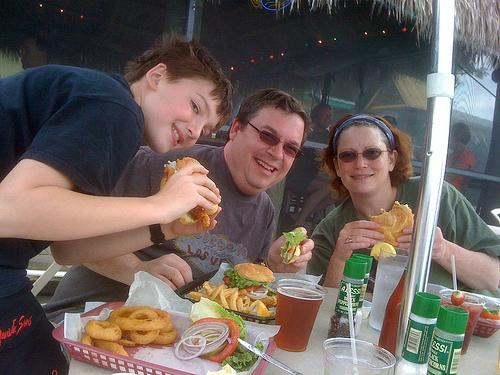Provide a description of the table items seen in the image. There are food baskets, a plastic glass of beer, two bottles of seasoning, a slice of lemon, and a straw in a cup on the table. Describe the interaction between the people in the image. A young boy and a woman are seen eating sandwiches and enjoying each other's company. Tell me the most prominent food item in the image. There is a prominent basket of huge homemade onion rings in the image. Identify a unique item present in the image along with the main food item. Unique item: decorative lights; Main food item: a basket of onion rings. Briefly explain what this picture portrays. The image showcases people enjoying their time eating various food items in a fun atmosphere. Describe the fashion statements made by the people in the image. A man is wearing a grey t-shirt and sunglasses, while a woman is wearing a green t-shirt and a blue headband. Mention one key event happening in the image. Two people are smiling and laughing together in the image. Explain the overall atmosphere of the image. The image conveys a relaxed and joyful atmosphere with people enjoying different food items and having a good time. List one main attraction and one beverage in the image. Main attraction: huge homemade onion rings in a basket; Beverage: chilled imported beer in a plastic cup. Explain the primary food offerings available in the image. The image showcases a variety of food items such as onion rings, hamburgers, sandwiches, and french fries being enjoyed by people. 